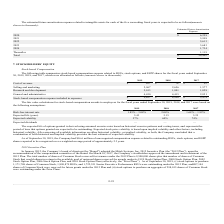According to Mitek Systems's financial document, What does the table provide for us? stock-based compensation expense related to RSUs, stock options, and ESPP shares for the fiscal years ended September 30, 2019, 2018, and 2017. The document states: "The following table summarizes stock-based compensation expense related to RSUs, stock options, and ESPP shares for the fiscal years ended September 3..." Also, What are the stock-based compensation expenses for research and development in 2017, 2018, and 2019, respectively? The document contains multiple relevant values: 1,028, 1,801, 2,013 (in thousands). From the document: "Research and development 2,013 1,801 1,028 Research and development 2,013 1,801 1,028 Research and development 2,013 1,801 1,028..." Also, What is the stock-based compensation expenses for selling and marketing in 2018? According to the financial document, 2,656 (in thousands). The relevant text states: "Selling and marketing 2,967 2,656 1,577..." Also, can you calculate: What is the percentage change in the cost of revenue between 2017 and 2019? To answer this question, I need to perform calculations using the financial data. The calculation is: (207-52)/52 , which equals 298.08 (percentage). This is based on the information: "Cost of revenue $ 207 $ 78 $ 52 Cost of revenue $ 207 $ 78 $ 52..." The key data points involved are: 207, 52. Also, can you calculate: What is the average expense of general and administrative from 2017 to 2019? To answer this question, I need to perform calculations using the financial data. The calculation is: (4,450+4,415+2,821)/3 , which equals 3895.33 (in thousands). This is based on the information: "General and administrative 4,450 4,415 2,821 General and administrative 4,450 4,415 2,821 General and administrative 4,450 4,415 2,821..." The key data points involved are: 2,821, 4,415, 4,450. Also, can you calculate: What is the proportion of selling and marketing, as well as general and administrative over total stock-based compensation expense in 2017? To answer this question, I need to perform calculations using the financial data. The calculation is: (1,577+2,821)/5,478 , which equals 0.8. This is based on the information: "on expense included in expenses $ 9,637 $ 8,950 $ 5,478 General and administrative 4,450 4,415 2,821 Selling and marketing 2,967 2,656 1,577..." The key data points involved are: 1,577, 2,821, 5,478. 